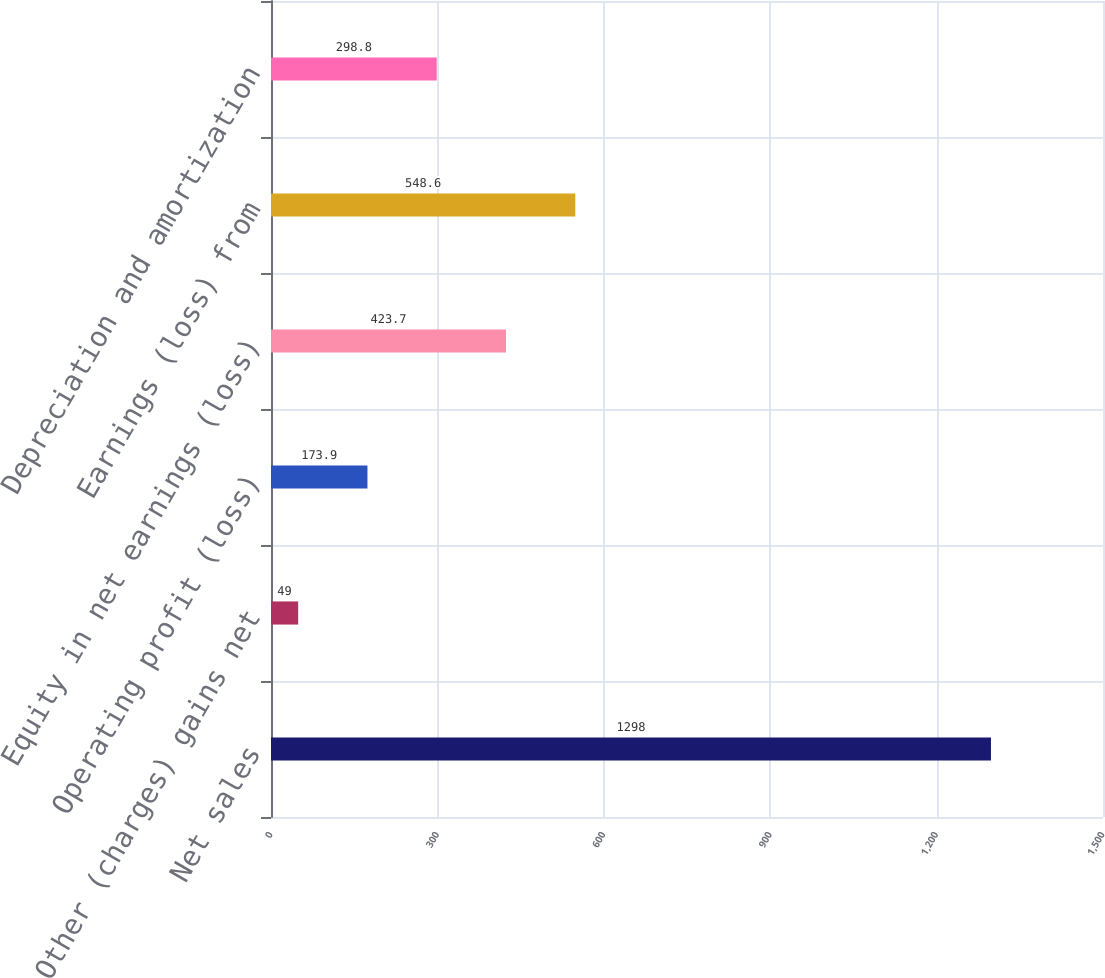Convert chart. <chart><loc_0><loc_0><loc_500><loc_500><bar_chart><fcel>Net sales<fcel>Other (charges) gains net<fcel>Operating profit (loss)<fcel>Equity in net earnings (loss)<fcel>Earnings (loss) from<fcel>Depreciation and amortization<nl><fcel>1298<fcel>49<fcel>173.9<fcel>423.7<fcel>548.6<fcel>298.8<nl></chart> 